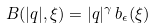Convert formula to latex. <formula><loc_0><loc_0><loc_500><loc_500>B ( | q | , \xi ) = | q | ^ { \gamma } \, { b } _ { \epsilon } ( \xi )</formula> 